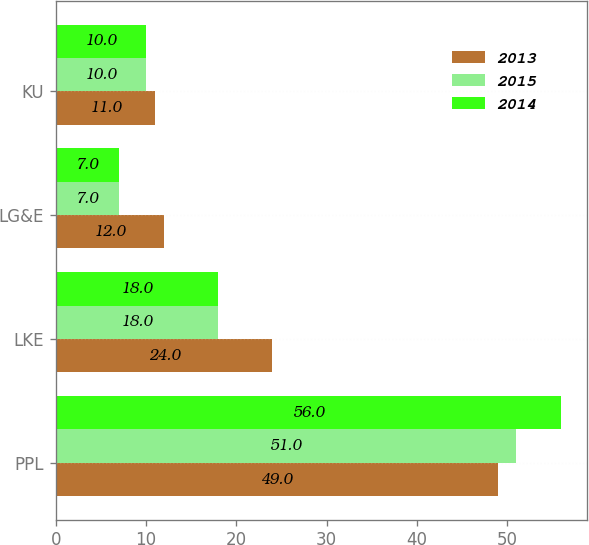Convert chart. <chart><loc_0><loc_0><loc_500><loc_500><stacked_bar_chart><ecel><fcel>PPL<fcel>LKE<fcel>LG&E<fcel>KU<nl><fcel>2013<fcel>49<fcel>24<fcel>12<fcel>11<nl><fcel>2015<fcel>51<fcel>18<fcel>7<fcel>10<nl><fcel>2014<fcel>56<fcel>18<fcel>7<fcel>10<nl></chart> 